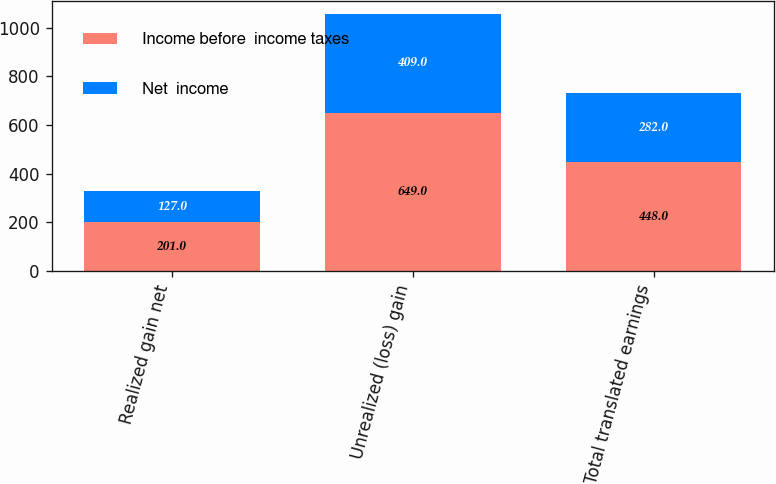Convert chart. <chart><loc_0><loc_0><loc_500><loc_500><stacked_bar_chart><ecel><fcel>Realized gain net<fcel>Unrealized (loss) gain<fcel>Total translated earnings<nl><fcel>Income before  income taxes<fcel>201<fcel>649<fcel>448<nl><fcel>Net  income<fcel>127<fcel>409<fcel>282<nl></chart> 